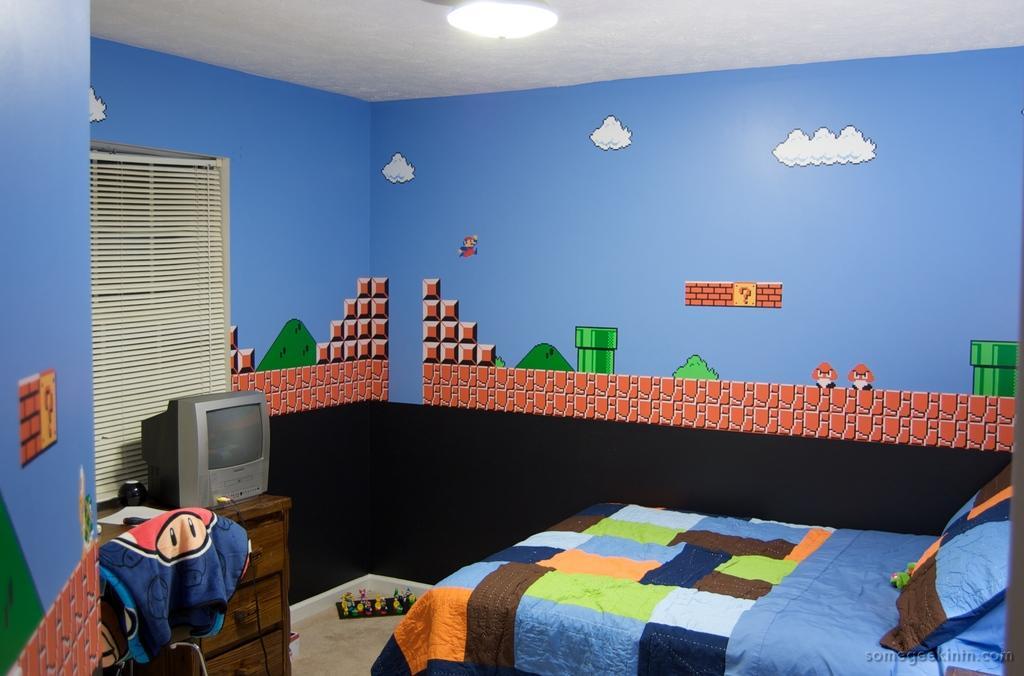Could you give a brief overview of what you see in this image? In this image we can see a bed with a pillow. In the back there is a wall with painting. Also there is a curtain. And there is a TV on the wooden stand with drawers. There is a cloth. On the ceiling there is light. 